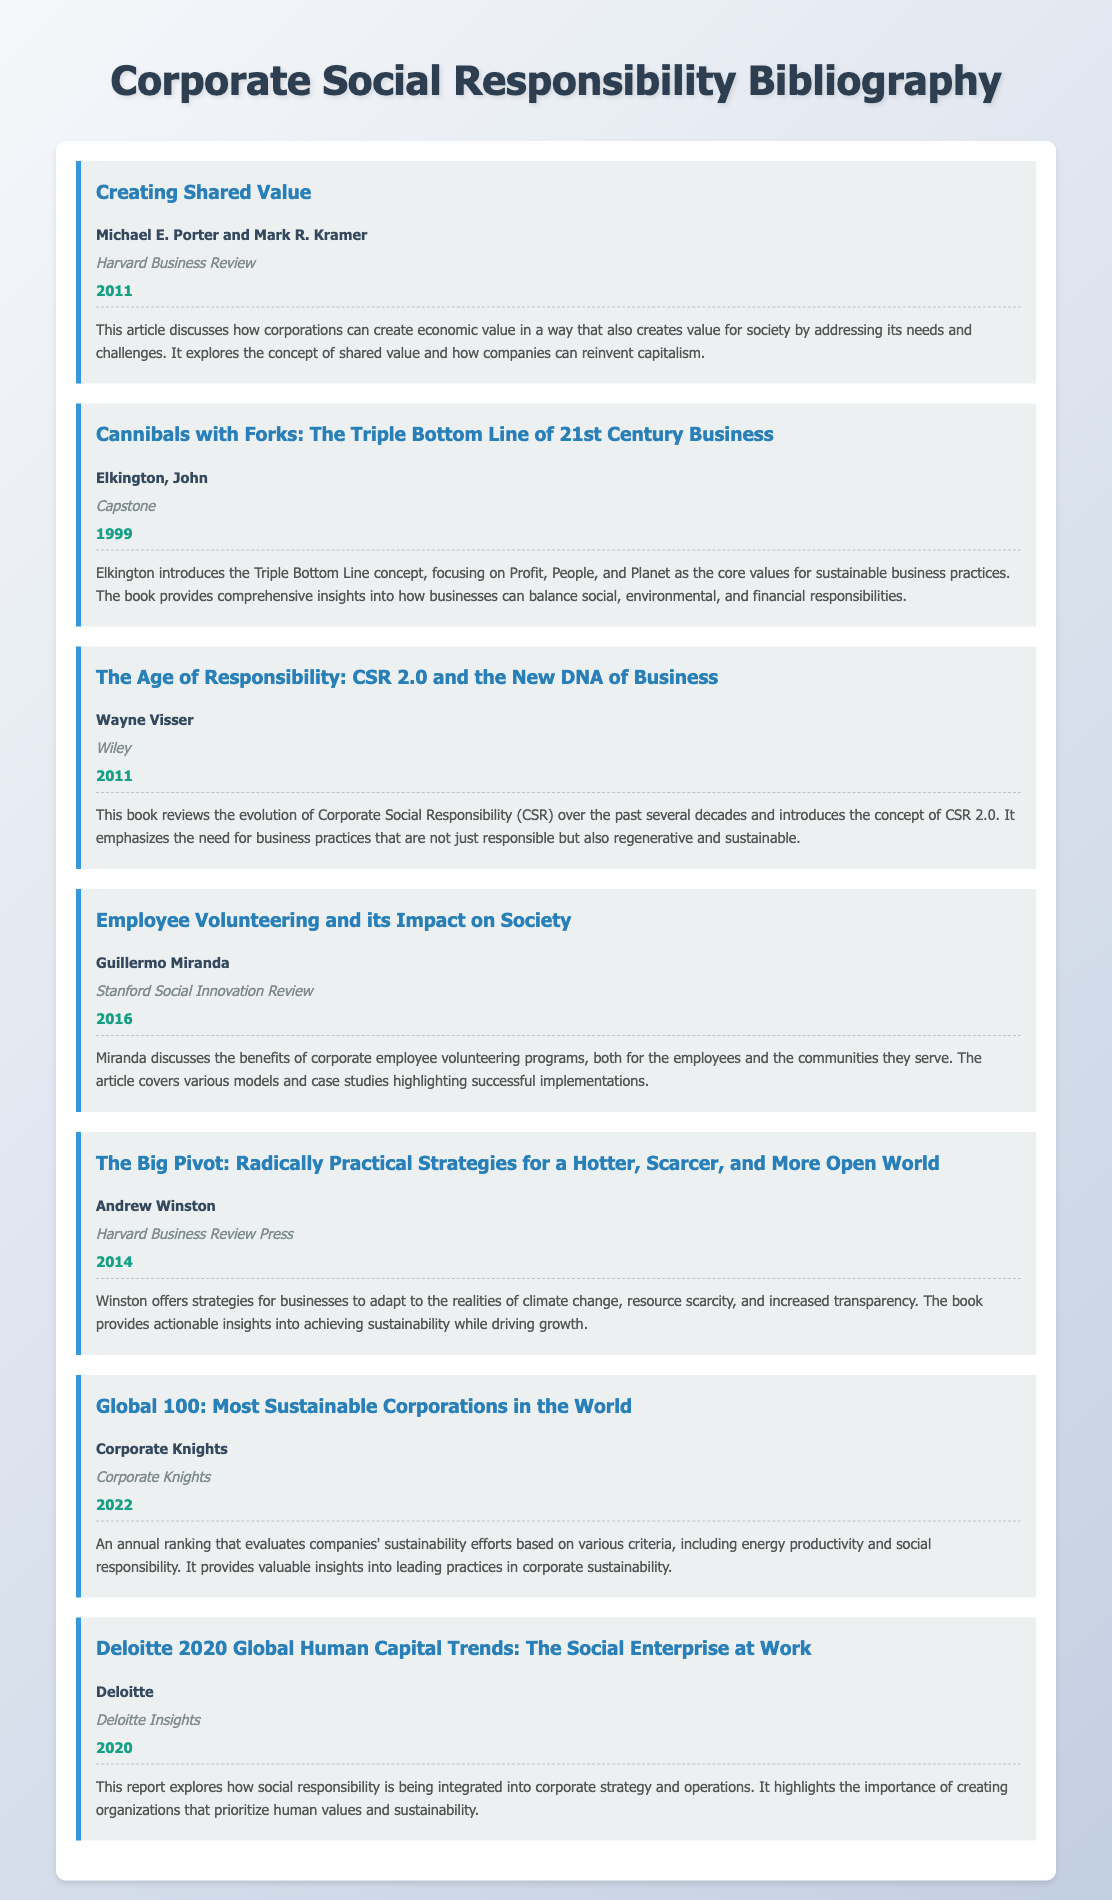what is the title of the article by Michael E. Porter? The title is listed clearly under his entry in the bibliography.
Answer: Creating Shared Value who are the authors of the book "Cannibals with Forks"? The authors' names are mentioned directly in the bibliography entry.
Answer: John Elkington in what year was "The Age of Responsibility" published? The year is provided in the bibliographic information for this entry.
Answer: 2011 what is the main topic of Guillermo Miranda's article? The topic can be inferred from the title and details provided in the bibliography entry.
Answer: Employee Volunteering which publisher released "The Big Pivot"? The publisher is stated clearly in the document's entry for this book.
Answer: Harvard Business Review Press how many years after the "Triple Bottom Line" concept was the Global 100 report published? The report's publication year is provided, and the concept's introduction year can be used for calculation.
Answer: 23 years what type of initiatives does the Deloitte report discuss? The specific type of initiatives is indicated in the title and description of the report entry.
Answer: Social Responsibility who published the "Global 100: Most Sustainable Corporations in the World"? The publisher is explicitly mentioned in the bibliography entry.
Answer: Corporate Knights 